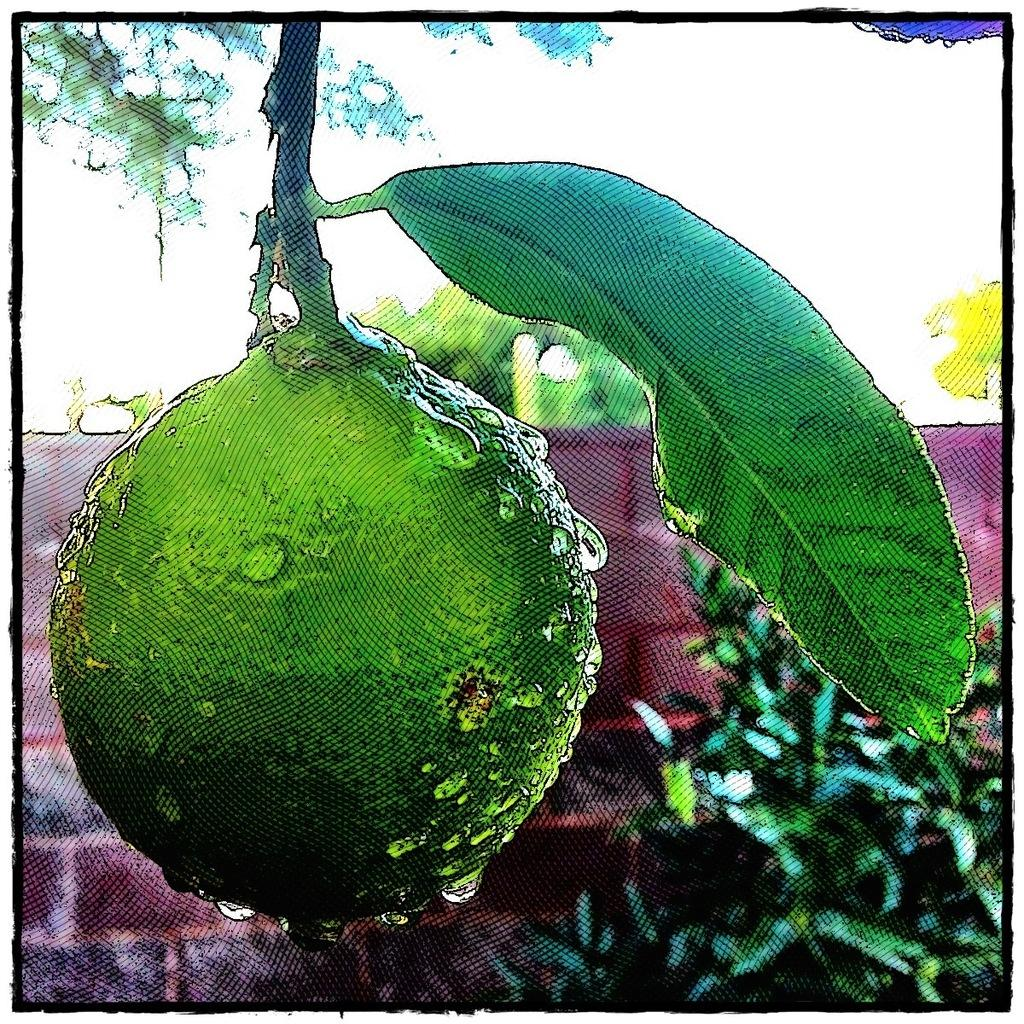What type of fruit is present in the image? The image contains a green color fruit. What can be observed on the fruit? The fruit has a stem and a leaf. What is located at the bottom of the image? There are plants at the bottom of the image. What can be seen in the background of the image? There is a wall and trees in the background of the image. How many attempts does the fruit make to control the wall in the image? The fruit does not attempt to control the wall in the image; it is a stationary object. 